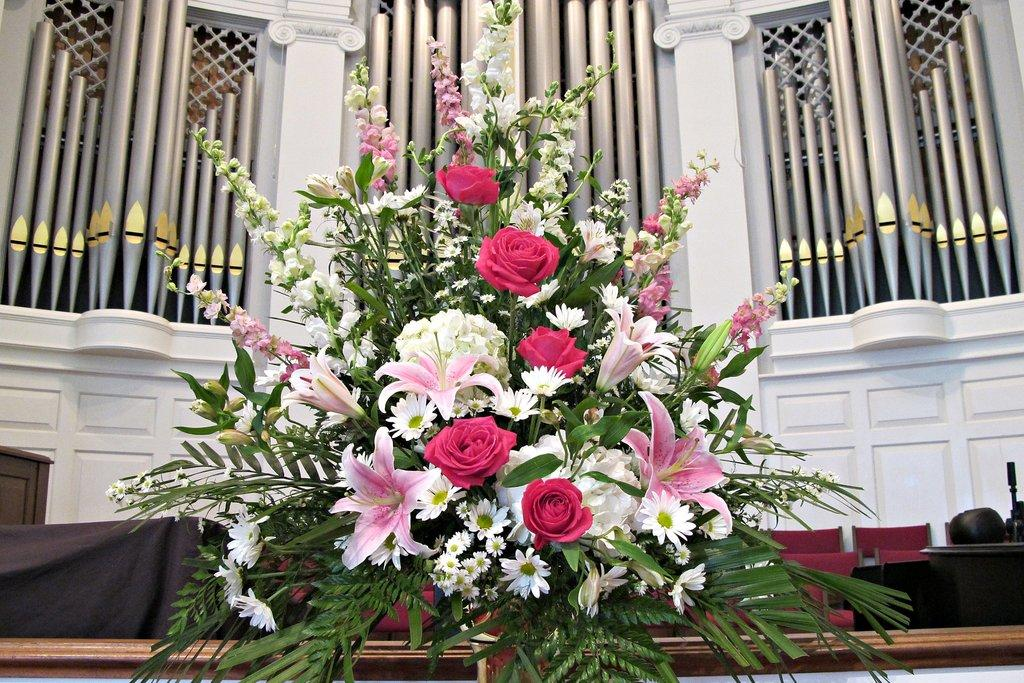What is the main subject of the image? There is a flower bouquet in the image. What else can be seen in the image besides the flower bouquet? A: There are chairs and a piece of cloth visible in the image. What is the background of the image like? There is a decorative wall in the background of the image. How many brushes are used to clean the bomb in the image? There is no bomb or brushes present in the image. 